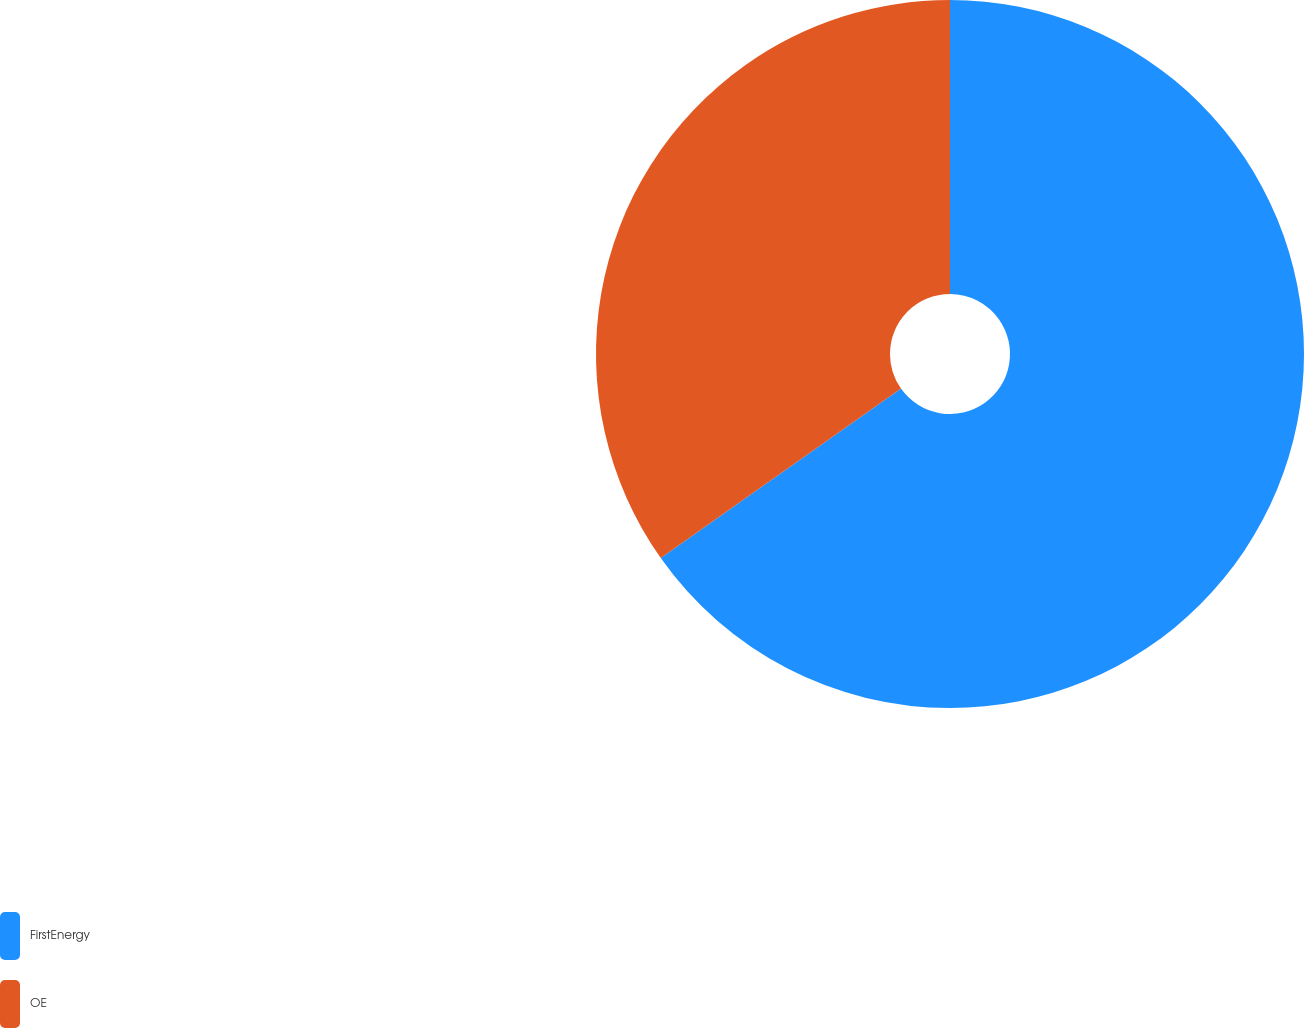Convert chart to OTSL. <chart><loc_0><loc_0><loc_500><loc_500><pie_chart><fcel>FirstEnergy<fcel>OE<nl><fcel>65.22%<fcel>34.78%<nl></chart> 